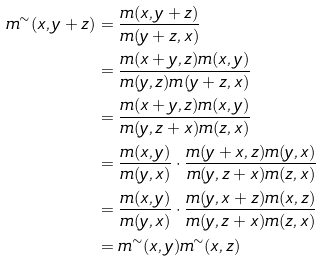Convert formula to latex. <formula><loc_0><loc_0><loc_500><loc_500>m ^ { \sim } ( x , y + z ) & = \frac { m ( x , y + z ) } { m ( y + z , x ) } \\ & = \frac { m ( x + y , z ) m ( x , y ) } { m ( y , z ) m ( y + z , x ) } \\ & = \frac { m ( x + y , z ) m ( x , y ) } { m ( y , z + x ) m ( z , x ) } \\ & = \frac { m ( x , y ) } { m ( y , x ) } \cdot \frac { m ( y + x , z ) m ( y , x ) } { m ( y , z + x ) m ( z , x ) } \\ & = \frac { m ( x , y ) } { m ( y , x ) } \cdot \frac { m ( y , x + z ) m ( x , z ) } { m ( y , z + x ) m ( z , x ) } \\ & = m ^ { \sim } ( x , y ) m ^ { \sim } ( x , z )</formula> 